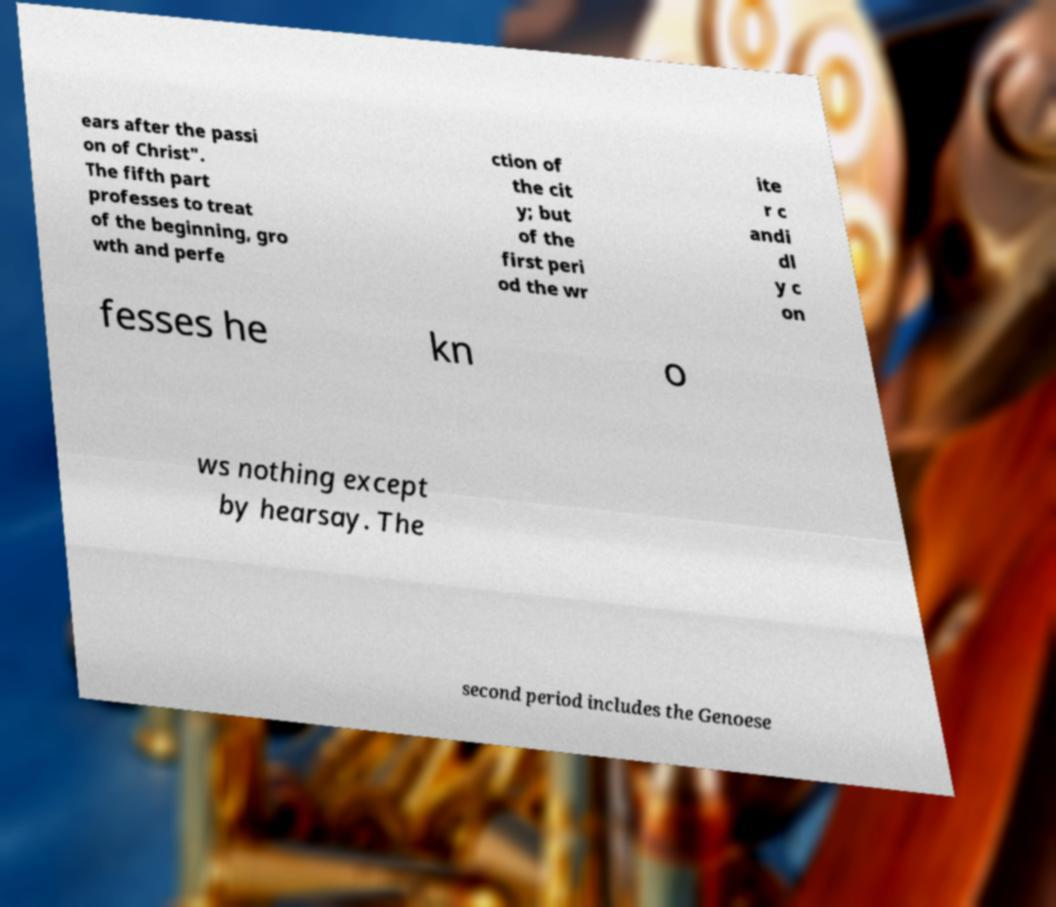For documentation purposes, I need the text within this image transcribed. Could you provide that? ears after the passi on of Christ". The fifth part professes to treat of the beginning, gro wth and perfe ction of the cit y; but of the first peri od the wr ite r c andi dl y c on fesses he kn o ws nothing except by hearsay. The second period includes the Genoese 